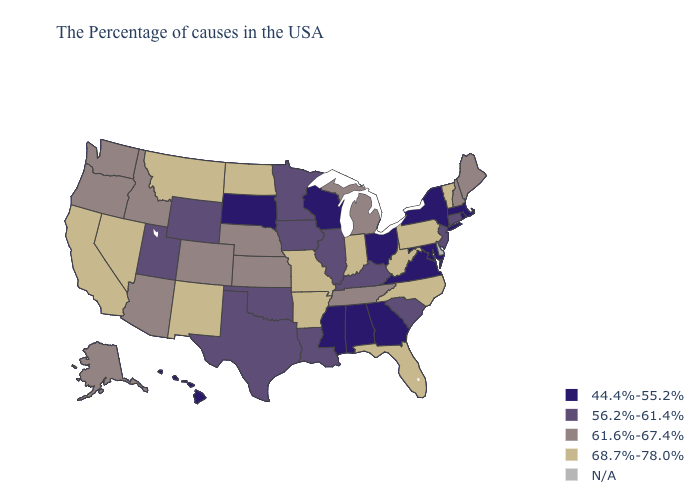Name the states that have a value in the range 68.7%-78.0%?
Give a very brief answer. Vermont, Pennsylvania, North Carolina, West Virginia, Florida, Indiana, Missouri, Arkansas, North Dakota, New Mexico, Montana, Nevada, California. How many symbols are there in the legend?
Keep it brief. 5. What is the lowest value in states that border Arkansas?
Short answer required. 44.4%-55.2%. What is the highest value in states that border Pennsylvania?
Quick response, please. 68.7%-78.0%. What is the lowest value in the USA?
Be succinct. 44.4%-55.2%. What is the lowest value in the USA?
Concise answer only. 44.4%-55.2%. Among the states that border Colorado , which have the lowest value?
Answer briefly. Oklahoma, Wyoming, Utah. Is the legend a continuous bar?
Keep it brief. No. Does the first symbol in the legend represent the smallest category?
Concise answer only. Yes. Which states have the lowest value in the MidWest?
Be succinct. Ohio, Wisconsin, South Dakota. How many symbols are there in the legend?
Answer briefly. 5. What is the highest value in the Northeast ?
Be succinct. 68.7%-78.0%. What is the value of Oklahoma?
Give a very brief answer. 56.2%-61.4%. Name the states that have a value in the range 56.2%-61.4%?
Short answer required. Connecticut, New Jersey, South Carolina, Kentucky, Illinois, Louisiana, Minnesota, Iowa, Oklahoma, Texas, Wyoming, Utah. What is the value of Delaware?
Quick response, please. N/A. 